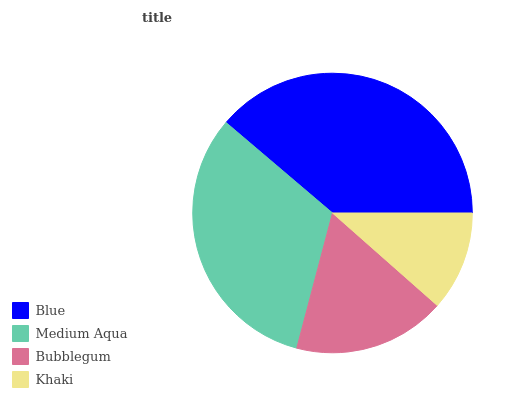Is Khaki the minimum?
Answer yes or no. Yes. Is Blue the maximum?
Answer yes or no. Yes. Is Medium Aqua the minimum?
Answer yes or no. No. Is Medium Aqua the maximum?
Answer yes or no. No. Is Blue greater than Medium Aqua?
Answer yes or no. Yes. Is Medium Aqua less than Blue?
Answer yes or no. Yes. Is Medium Aqua greater than Blue?
Answer yes or no. No. Is Blue less than Medium Aqua?
Answer yes or no. No. Is Medium Aqua the high median?
Answer yes or no. Yes. Is Bubblegum the low median?
Answer yes or no. Yes. Is Blue the high median?
Answer yes or no. No. Is Khaki the low median?
Answer yes or no. No. 